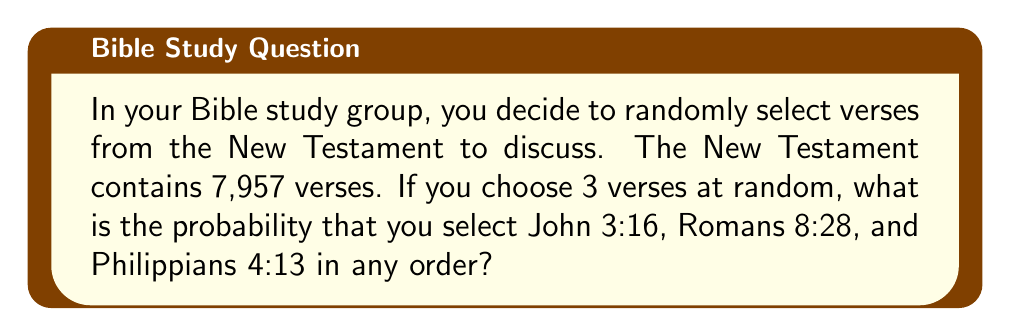Teach me how to tackle this problem. Let's approach this step-by-step:

1) First, we need to understand that the order doesn't matter. We're looking for the probability of selecting these specific 3 verses out of all possible combinations of 3 verses from the New Testament.

2) This is a combination problem. We can use the concept of favorable outcomes divided by total possible outcomes.

3) Favorable outcomes: There is only 1 way to select these specific 3 verses.

4) Total possible outcomes: This is the number of ways to choose 3 verses from 7,957 verses, which is represented by the combination formula:

   $$\binom{7957}{3} = \frac{7957!}{3!(7957-3)!} = \frac{7957!}{3!7954!}$$

5) Calculate this:
   $$\binom{7957}{3} = \frac{7957 \cdot 7956 \cdot 7955}{3 \cdot 2 \cdot 1} = 8,417,822,220$$

6) The probability is then:

   $$P(\text{selecting those 3 verses}) = \frac{\text{favorable outcomes}}{\text{total possible outcomes}} = \frac{1}{8,417,822,220}$$

7) This can be simplified to:

   $$P = \frac{1}{8,417,822,220} \approx 1.188 \times 10^{-10}$$
Answer: $1.188 \times 10^{-10}$ 